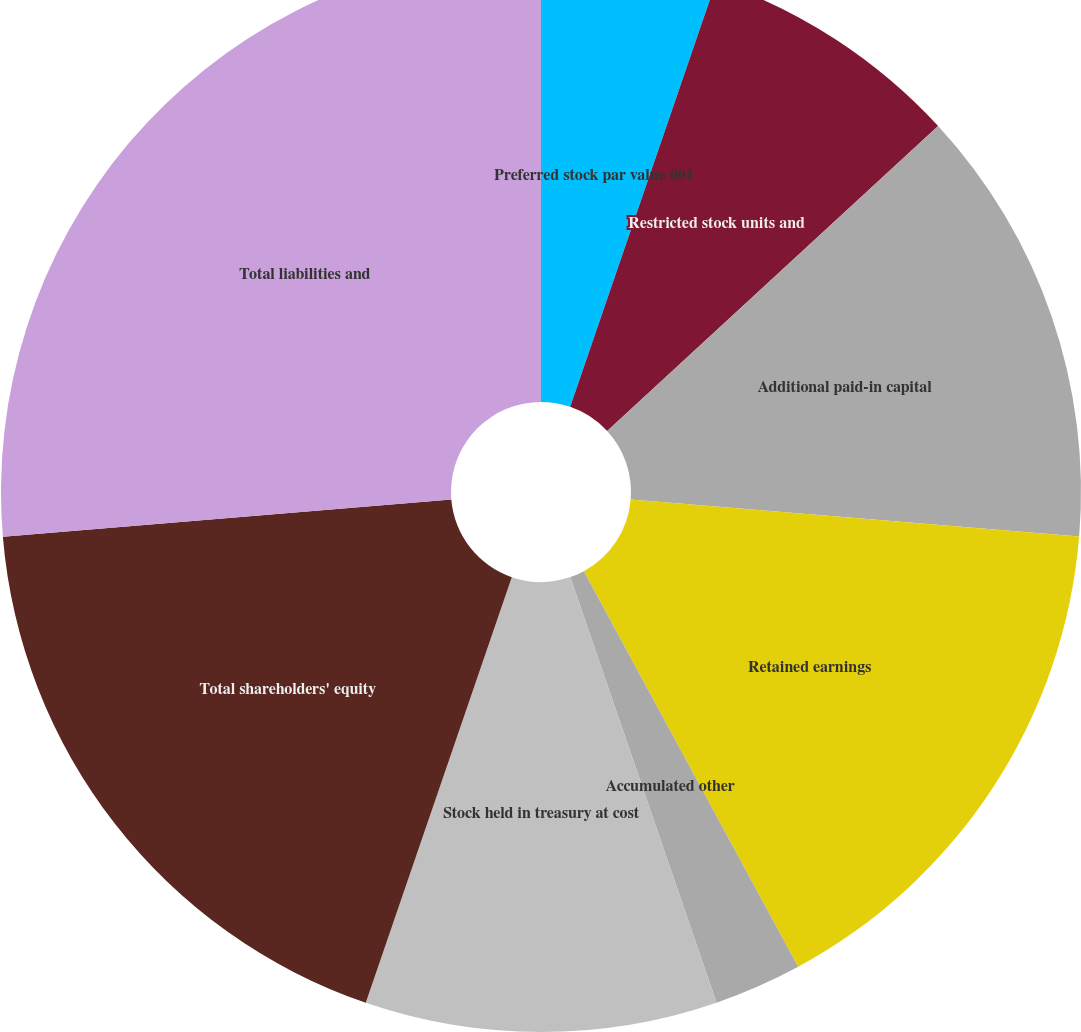Convert chart to OTSL. <chart><loc_0><loc_0><loc_500><loc_500><pie_chart><fcel>Preferred stock par value 001<fcel>Common stock par value 001 per<fcel>Restricted stock units and<fcel>Additional paid-in capital<fcel>Retained earnings<fcel>Accumulated other<fcel>Stock held in treasury at cost<fcel>Total shareholders' equity<fcel>Total liabilities and<nl><fcel>5.26%<fcel>0.0%<fcel>7.89%<fcel>13.16%<fcel>15.79%<fcel>2.63%<fcel>10.53%<fcel>18.42%<fcel>26.32%<nl></chart> 